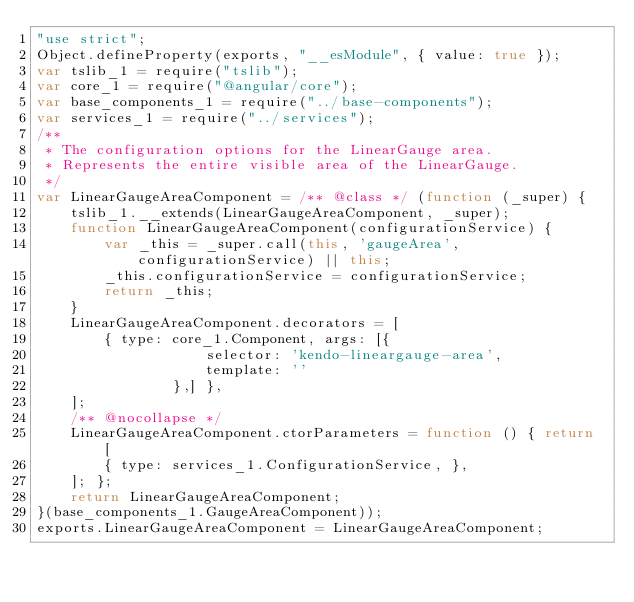<code> <loc_0><loc_0><loc_500><loc_500><_JavaScript_>"use strict";
Object.defineProperty(exports, "__esModule", { value: true });
var tslib_1 = require("tslib");
var core_1 = require("@angular/core");
var base_components_1 = require("../base-components");
var services_1 = require("../services");
/**
 * The configuration options for the LinearGauge area.
 * Represents the entire visible area of the LinearGauge.
 */
var LinearGaugeAreaComponent = /** @class */ (function (_super) {
    tslib_1.__extends(LinearGaugeAreaComponent, _super);
    function LinearGaugeAreaComponent(configurationService) {
        var _this = _super.call(this, 'gaugeArea', configurationService) || this;
        _this.configurationService = configurationService;
        return _this;
    }
    LinearGaugeAreaComponent.decorators = [
        { type: core_1.Component, args: [{
                    selector: 'kendo-lineargauge-area',
                    template: ''
                },] },
    ];
    /** @nocollapse */
    LinearGaugeAreaComponent.ctorParameters = function () { return [
        { type: services_1.ConfigurationService, },
    ]; };
    return LinearGaugeAreaComponent;
}(base_components_1.GaugeAreaComponent));
exports.LinearGaugeAreaComponent = LinearGaugeAreaComponent;
</code> 